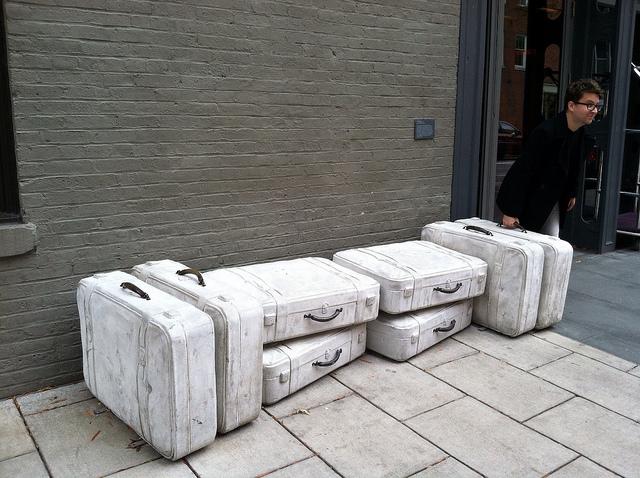What are the suitcases sitting on?
Write a very short answer. Ground. How many pieces of luggage are white?
Short answer required. 8. Who are the owners of the luggages?
Quick response, please. Man. How many suitcases are green?
Give a very brief answer. 0. Do these pieces of luggage match?
Be succinct. Yes. Is the picture indoors or outdoors?
Keep it brief. Outdoors. Has someone forgotten his luggage?
Quick response, please. No. What are the people who packed the luggage probably going to do?
Give a very brief answer. Travel. What  are the things on the sidewalk?
Short answer required. Suitcases. How many luggages are seen?
Be succinct. 8. How many cases are there?
Keep it brief. 8. Are there luggage tags?
Answer briefly. No. 